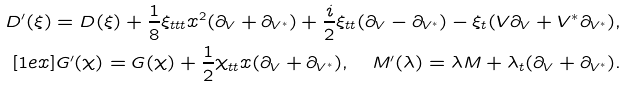<formula> <loc_0><loc_0><loc_500><loc_500>D ^ { \prime } ( \xi ) = D ( \xi ) + \frac { 1 } { 8 } \xi _ { t t t } x ^ { 2 } ( \partial _ { V } + \partial _ { V ^ { * } } ) + \frac { i } { 2 } \xi _ { t t } ( \partial _ { V } - \partial _ { V ^ { * } } ) - \xi _ { t } ( V \partial _ { V } + { V ^ { * } } \partial _ { V ^ { * } } ) , \\ [ 1 e x ] G ^ { \prime } ( \chi ) = G ( \chi ) + \frac { 1 } { 2 } \chi _ { t t } x ( \partial _ { V } + \partial _ { V ^ { * } } ) , \quad M ^ { \prime } ( \lambda ) = \lambda M + \lambda _ { t } ( \partial _ { V } + \partial _ { V ^ { * } } ) .</formula> 